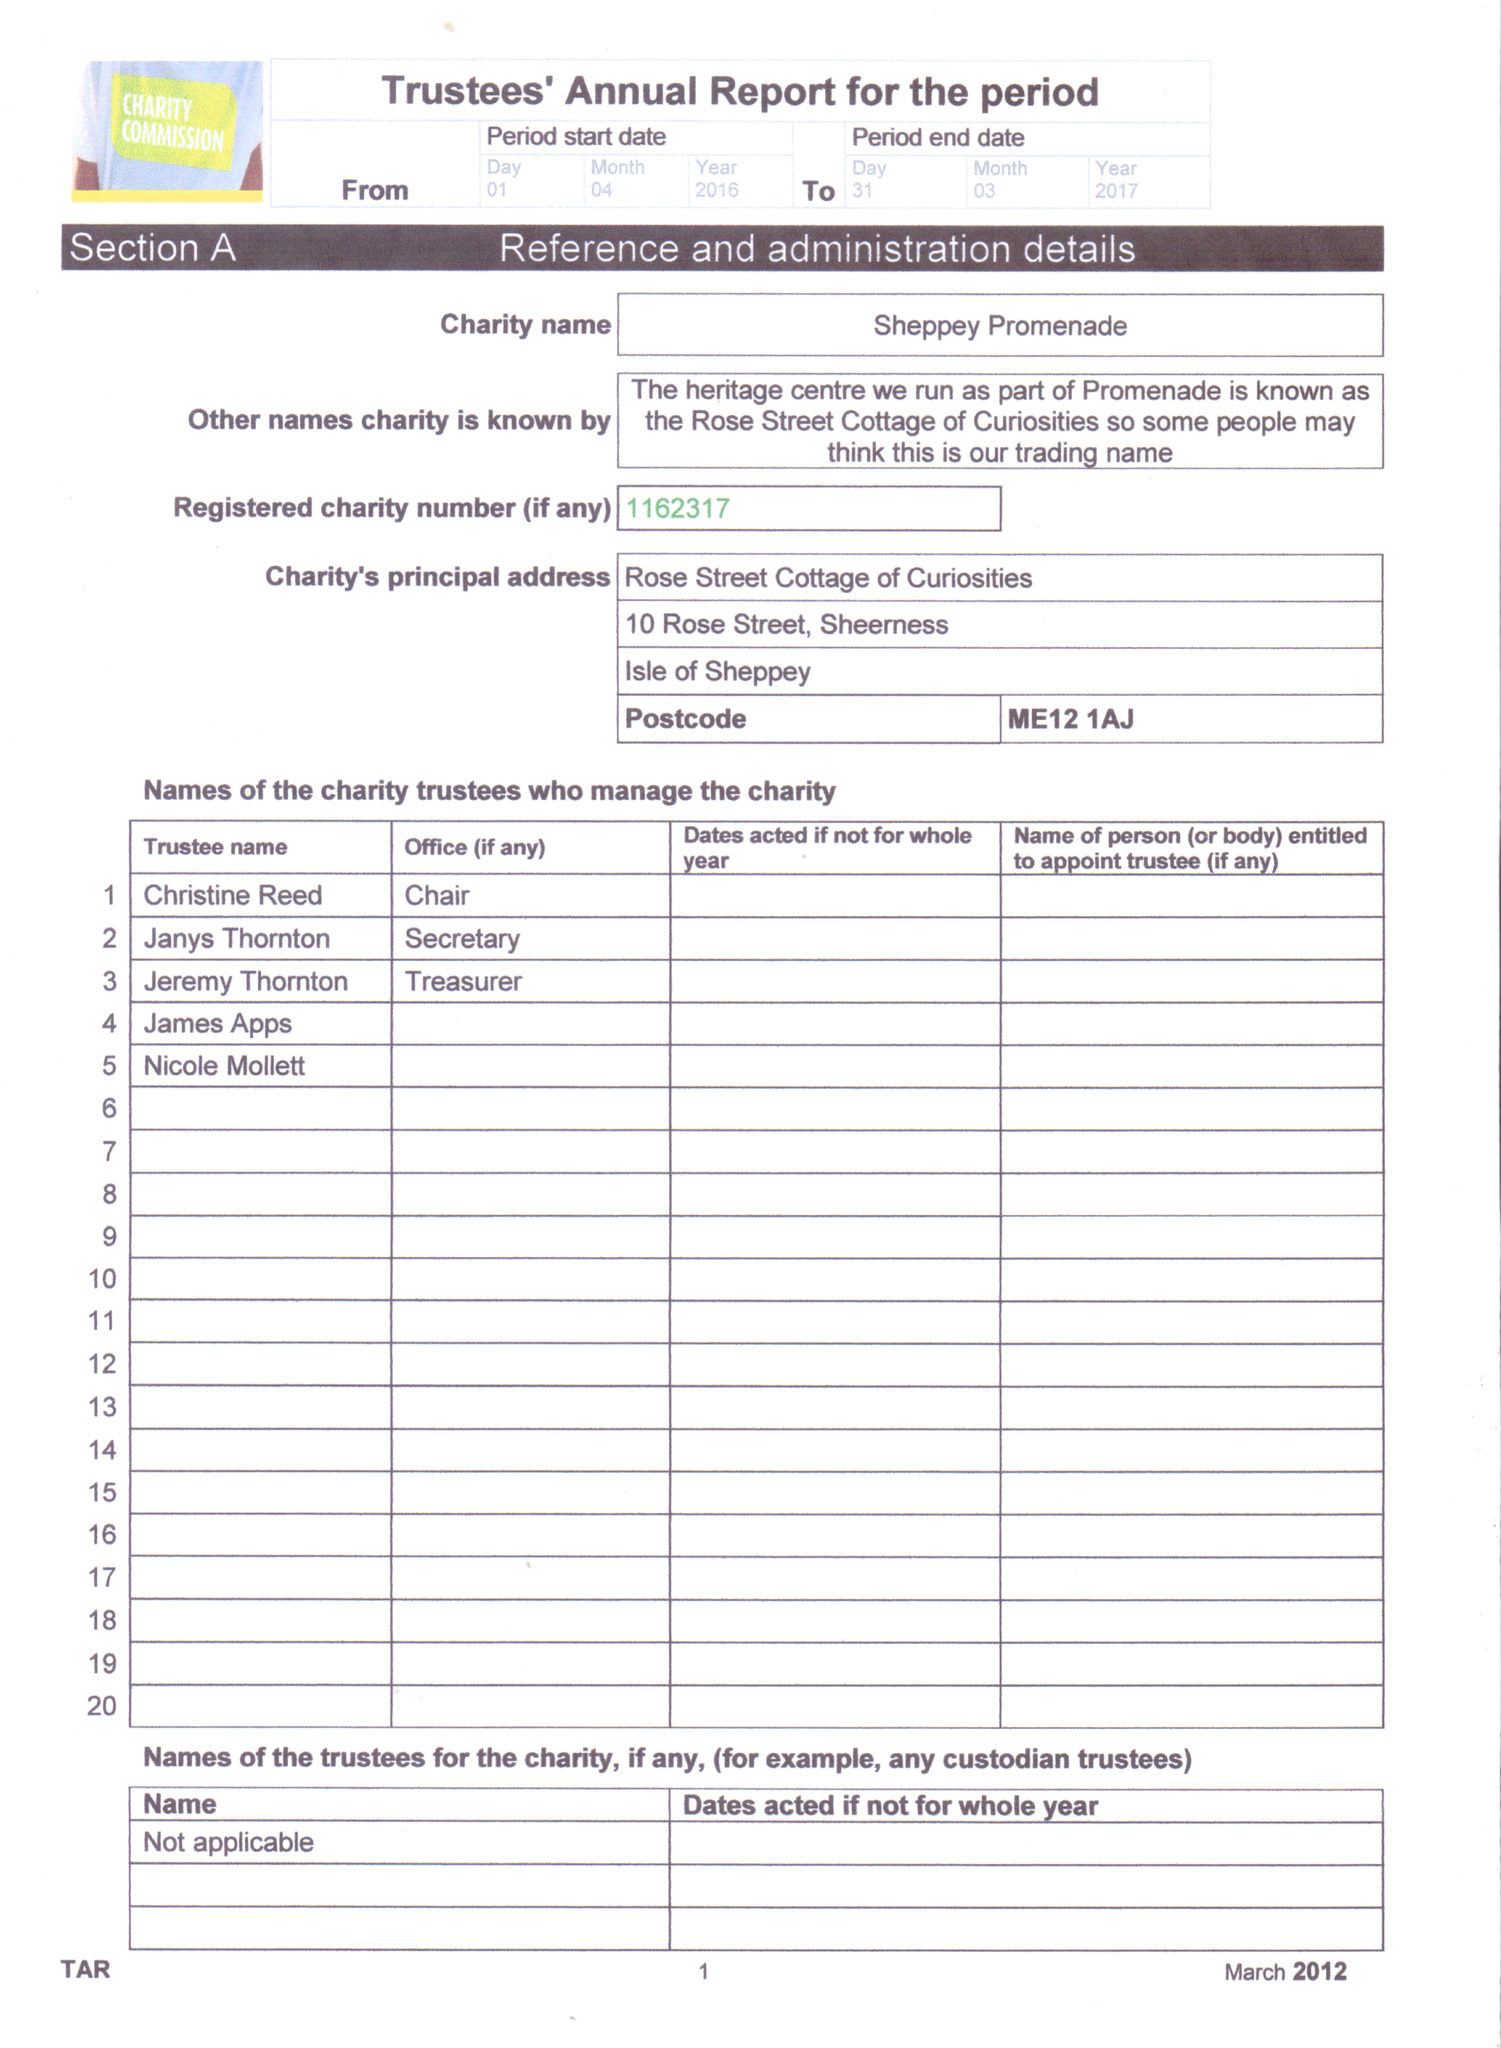What is the value for the charity_number?
Answer the question using a single word or phrase. 1162317 